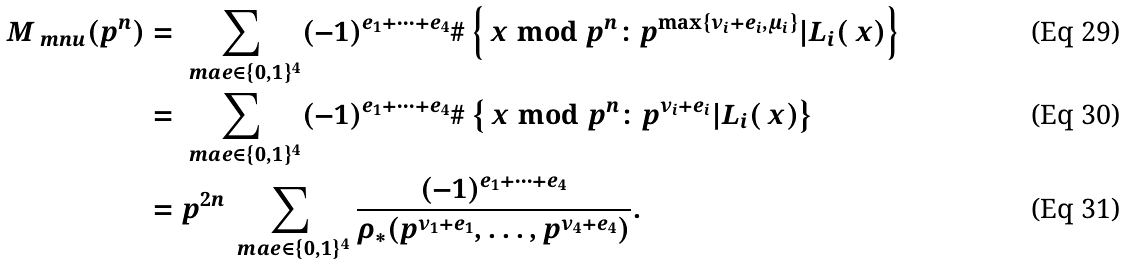Convert formula to latex. <formula><loc_0><loc_0><loc_500><loc_500>M _ { \ m n u } ( p ^ { n } ) & = \sum _ { \ m a { e } \in \{ 0 , 1 \} ^ { 4 } } ( - 1 ) ^ { e _ { 1 } + \cdots + e _ { 4 } } \# \left \{ \ x \bmod { p ^ { n } } \colon p ^ { \max \{ \nu _ { i } + e _ { i } , \mu _ { i } \} } | L _ { i } ( \ x ) \right \} \\ & = \sum _ { \ m a { e } \in \{ 0 , 1 \} ^ { 4 } } ( - 1 ) ^ { e _ { 1 } + \cdots + e _ { 4 } } \# \left \{ \ x \bmod { p ^ { n } } \colon p ^ { \nu _ { i } + e _ { i } } | L _ { i } ( \ x ) \right \} \\ & = p ^ { 2 n } \sum _ { \ m a { e } \in \{ 0 , 1 \} ^ { 4 } } \frac { ( - 1 ) ^ { e _ { 1 } + \cdots + e _ { 4 } } } { \rho _ { * } ( p ^ { \nu _ { 1 } + e _ { 1 } } , \dots , p ^ { \nu _ { 4 } + e _ { 4 } } ) } .</formula> 